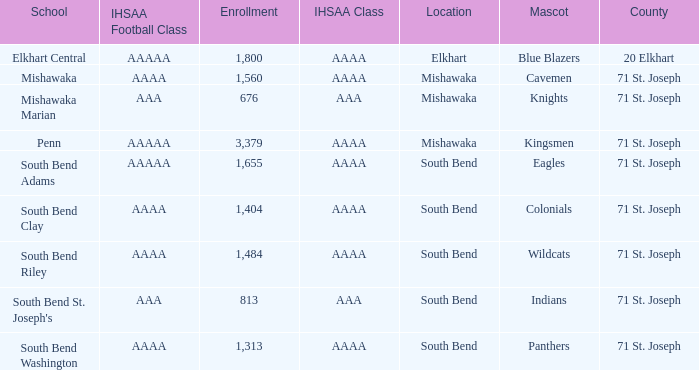What location has kingsmen as the mascot? Mishawaka. 